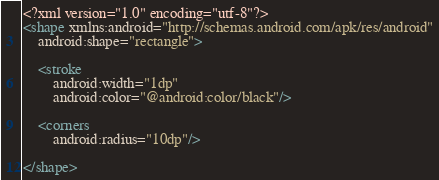Convert code to text. <code><loc_0><loc_0><loc_500><loc_500><_XML_><?xml version="1.0" encoding="utf-8"?>
<shape xmlns:android="http://schemas.android.com/apk/res/android"
    android:shape="rectangle">

    <stroke
        android:width="1dp"
        android:color="@android:color/black"/>

    <corners
        android:radius="10dp"/>

</shape></code> 